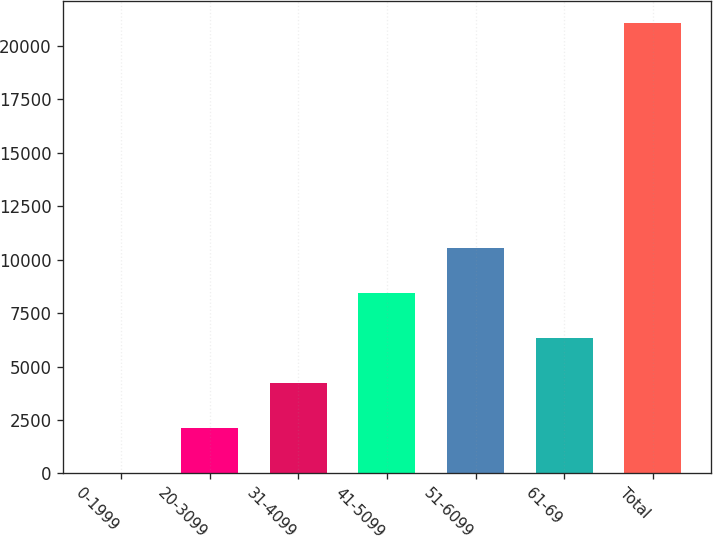Convert chart. <chart><loc_0><loc_0><loc_500><loc_500><bar_chart><fcel>0-1999<fcel>20-3099<fcel>31-4099<fcel>41-5099<fcel>51-6099<fcel>61-69<fcel>Total<nl><fcel>2<fcel>2107.5<fcel>4213<fcel>8424<fcel>10529.5<fcel>6318.5<fcel>21057<nl></chart> 